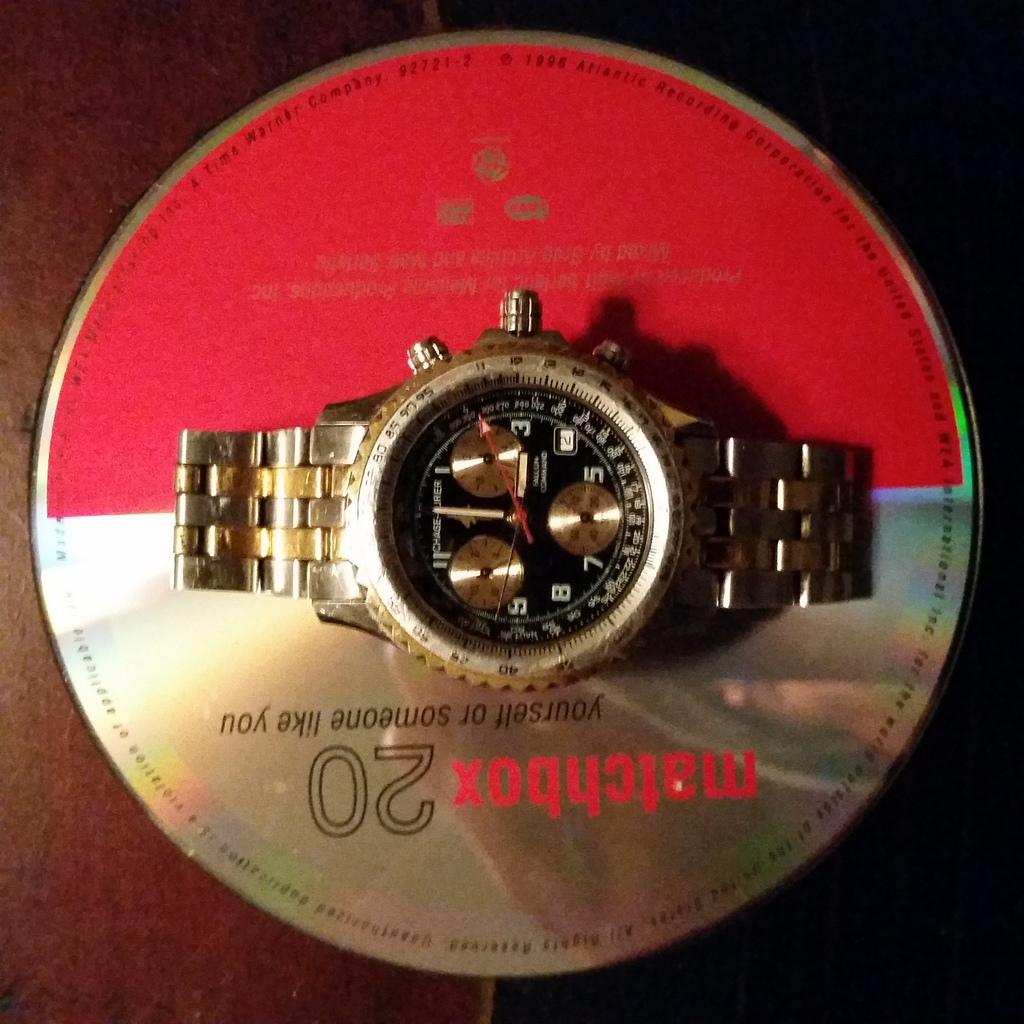What does it say in red on the cd?
Make the answer very short. Matchbox. What type of watch is this?
Your response must be concise. Unanswerable. 